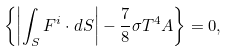Convert formula to latex. <formula><loc_0><loc_0><loc_500><loc_500>\left \{ \left | \int _ { S } { F } ^ { i } \cdot d { S } \right | - \frac { 7 } { 8 } \sigma T ^ { 4 } A \right \} = 0 ,</formula> 